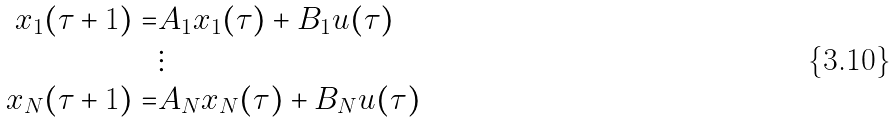Convert formula to latex. <formula><loc_0><loc_0><loc_500><loc_500>x _ { 1 } ( \tau + 1 ) = & A _ { 1 } x _ { 1 } ( \tau ) + B _ { 1 } u ( \tau ) \\ & \vdots \\ x _ { N } ( \tau + 1 ) = & A _ { N } x _ { N } ( \tau ) + B _ { N } u ( \tau )</formula> 